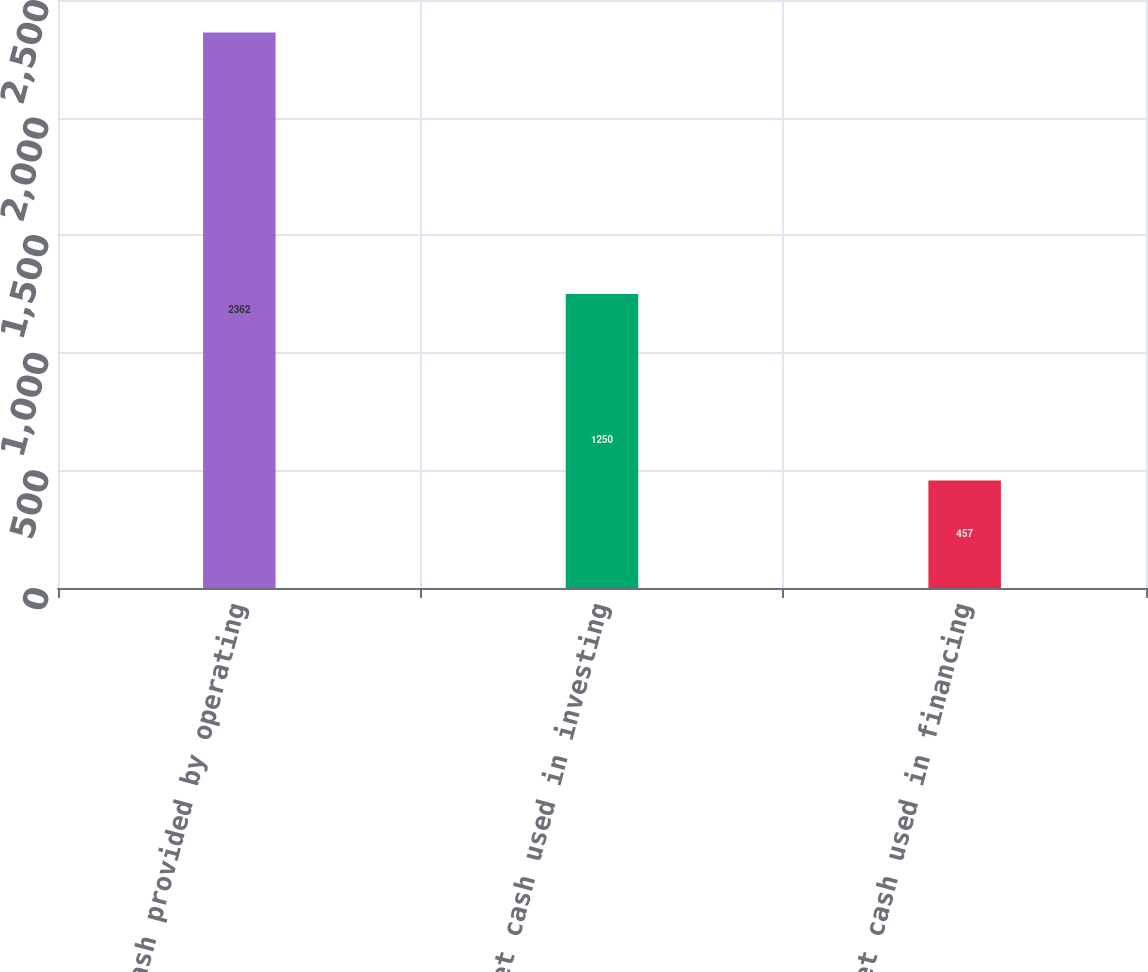Convert chart to OTSL. <chart><loc_0><loc_0><loc_500><loc_500><bar_chart><fcel>Net cash provided by operating<fcel>Net cash used in investing<fcel>Net cash used in financing<nl><fcel>2362<fcel>1250<fcel>457<nl></chart> 